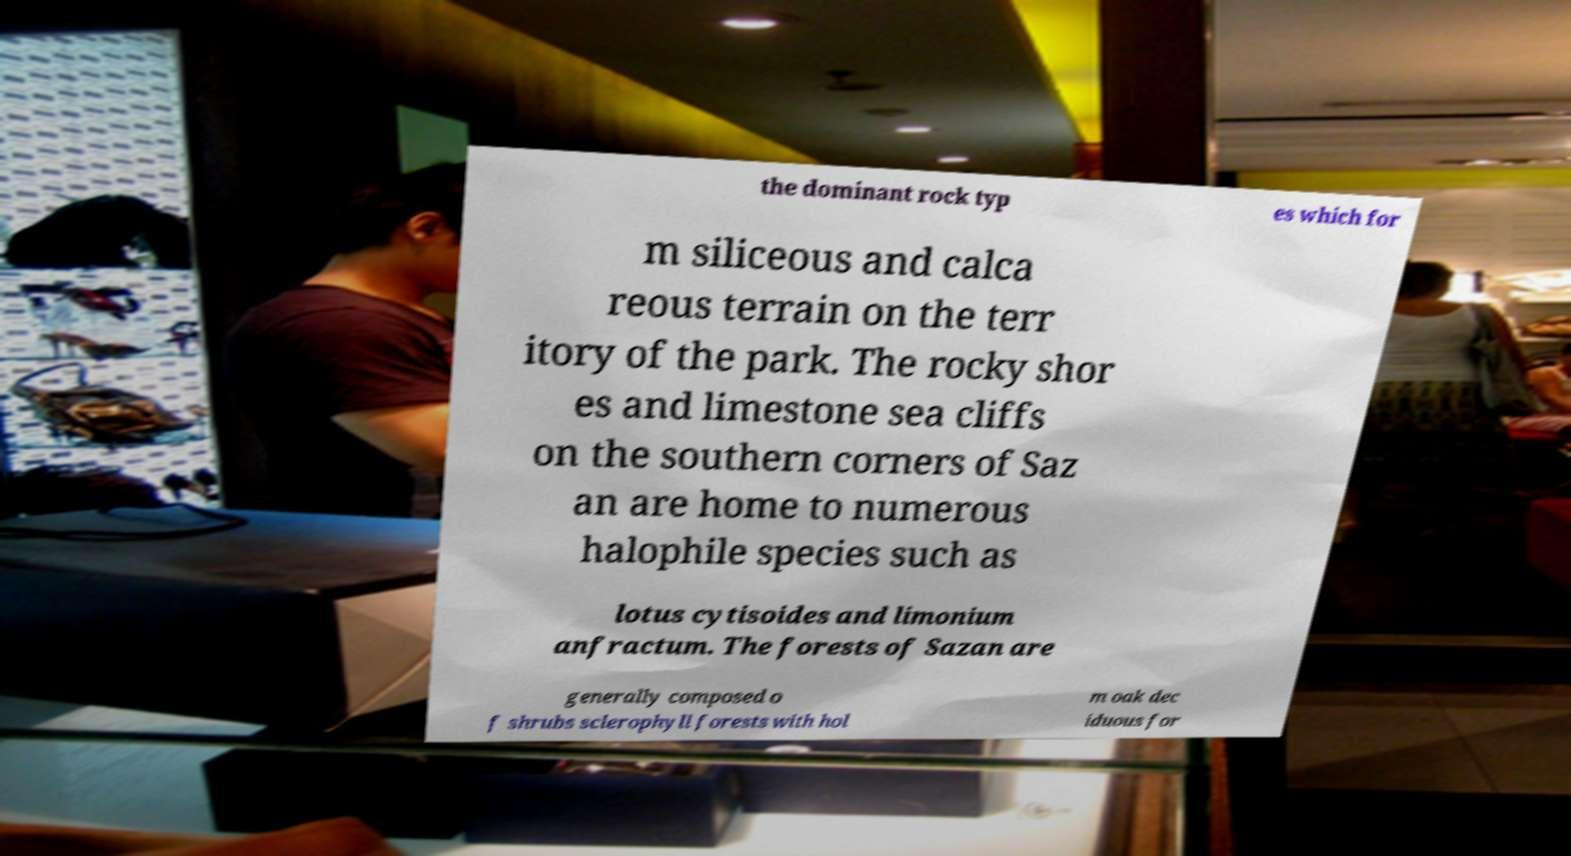Please read and relay the text visible in this image. What does it say? the dominant rock typ es which for m siliceous and calca reous terrain on the terr itory of the park. The rocky shor es and limestone sea cliffs on the southern corners of Saz an are home to numerous halophile species such as lotus cytisoides and limonium anfractum. The forests of Sazan are generally composed o f shrubs sclerophyll forests with hol m oak dec iduous for 